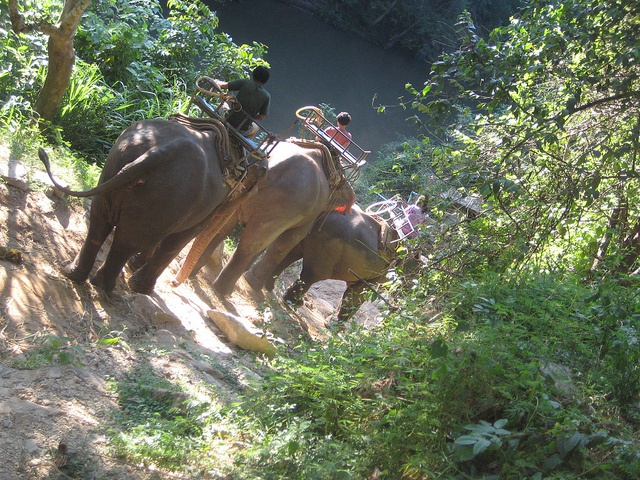Describe the objects in this image and their specific colors. I can see elephant in gray and black tones, elephant in gray and white tones, elephant in gray, black, and darkgray tones, people in gray, black, purple, and white tones, and people in gray, white, and darkgray tones in this image. 